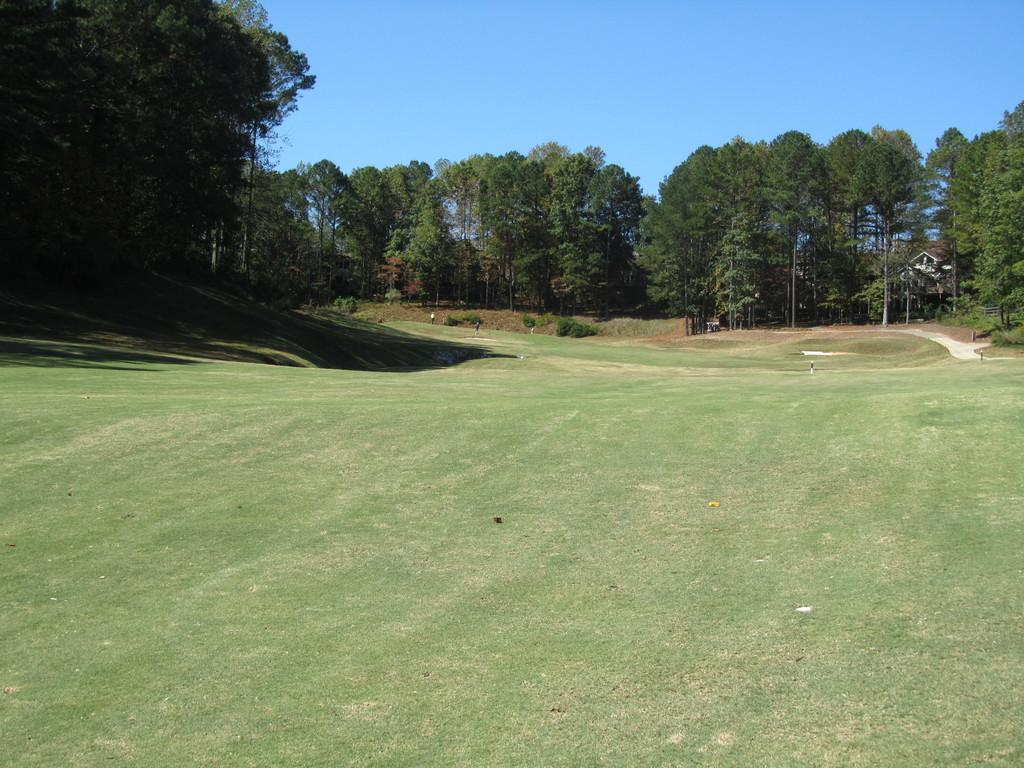What type of surface is visible in the image? There is ground visible in the image. What is covering the ground? There is grass on the ground. What other natural elements can be seen in the image? There are trees in the image. What colors are the trees? The trees are green and brown in color. What type of structure is present in the image? There is a house in the image. What is visible in the background of the image? The sky is visible in the background of the image. What type of fowl can be seen taking care of the view in the image? There is no fowl present in the image, and the concept of a fowl taking care of the view is not applicable. 